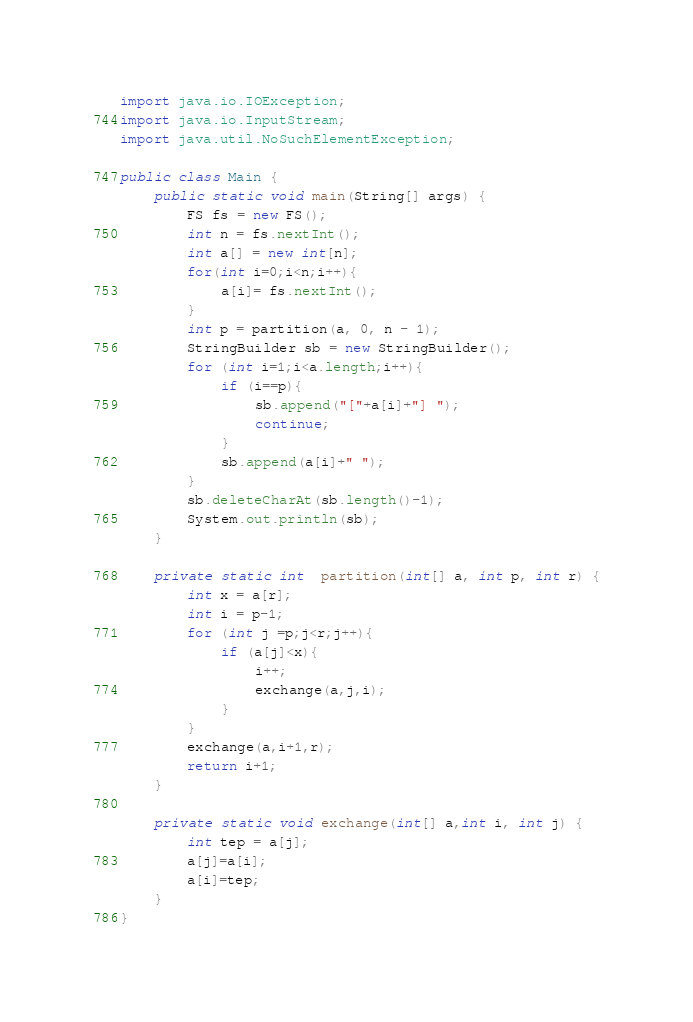<code> <loc_0><loc_0><loc_500><loc_500><_Java_>import java.io.IOException;
import java.io.InputStream;
import java.util.NoSuchElementException;

public class Main {
    public static void main(String[] args) {
        FS fs = new FS();
        int n = fs.nextInt();
        int a[] = new int[n];
        for(int i=0;i<n;i++){
            a[i]= fs.nextInt();
        }
        int p = partition(a, 0, n - 1);
        StringBuilder sb = new StringBuilder();
        for (int i=1;i<a.length;i++){
            if (i==p){
                sb.append("["+a[i]+"] ");
                continue;
            }
            sb.append(a[i]+" ");
        }
        sb.deleteCharAt(sb.length()-1);
        System.out.println(sb);
    }

    private static int  partition(int[] a, int p, int r) {
        int x = a[r];
        int i = p-1;
        for (int j =p;j<r;j++){
            if (a[j]<x){
                i++;
                exchange(a,j,i);
            }
        }
        exchange(a,i+1,r);
        return i+1;
    }

    private static void exchange(int[] a,int i, int j) {
        int tep = a[j];
        a[j]=a[i];
        a[i]=tep;
    }
}
</code> 